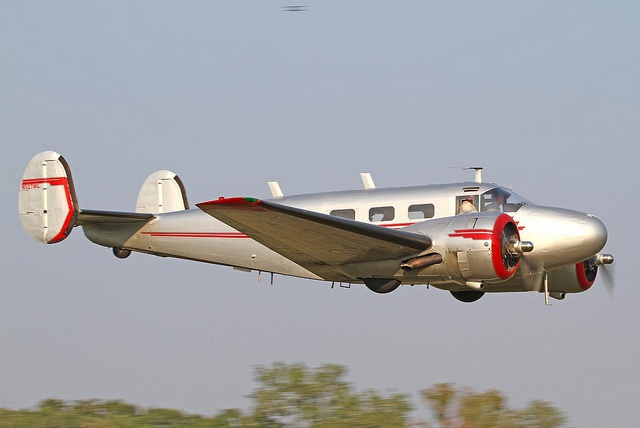Describe the objects in this image and their specific colors. I can see airplane in darkgray, gray, and ivory tones, people in darkgray, gray, and black tones, and people in darkgray and tan tones in this image. 